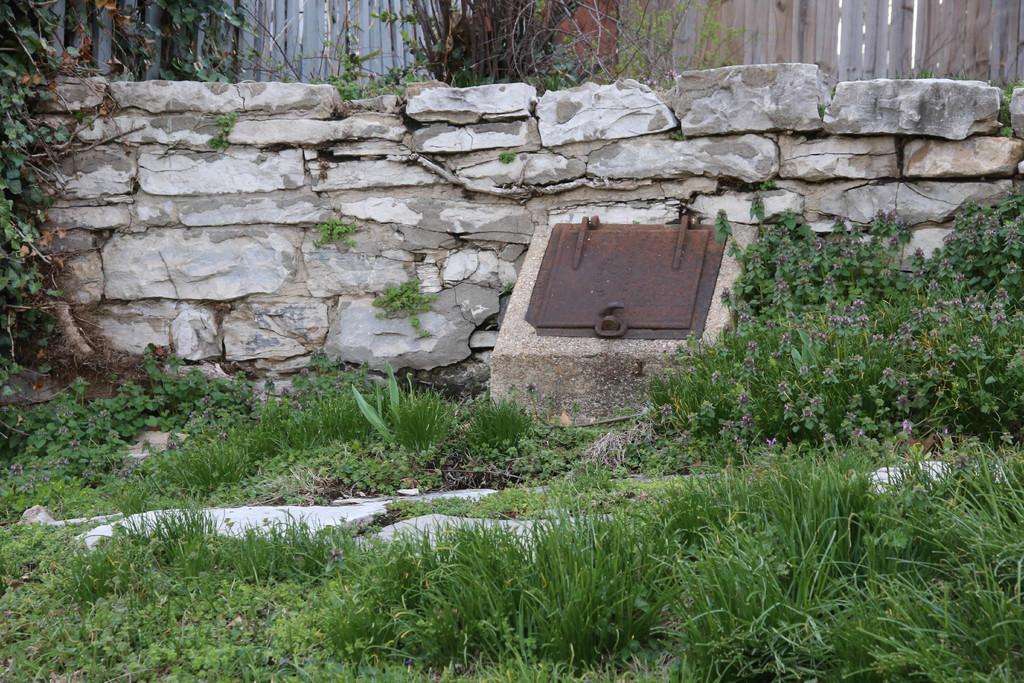Describe this image in one or two sentences. In this picture I can see there is grass, plants and there is a fence and a wall in the backdrop. There are also few trees. 